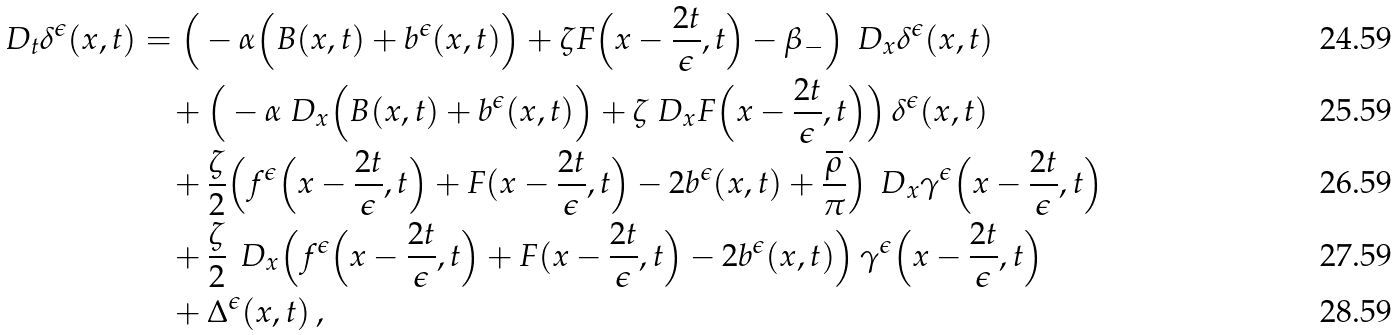Convert formula to latex. <formula><loc_0><loc_0><loc_500><loc_500>\ D _ { t } \delta ^ { \epsilon } ( x , t ) & = \Big ( - \alpha \Big ( B ( x , t ) + b ^ { \epsilon } ( x , t ) \Big ) + \zeta F \Big ( x - \frac { 2 t } { \epsilon } , t \Big ) - \beta _ { - } \Big ) \, \ D _ { x } \delta ^ { \epsilon } ( x , t ) \\ & \quad + \Big ( - \alpha \ D _ { x } \Big ( B ( x , t ) + b ^ { \epsilon } ( x , t ) \Big ) + \zeta \ D _ { x } F \Big ( x - \frac { 2 t } { \epsilon } , t \Big ) \Big ) \, \delta ^ { \epsilon } ( x , t ) \\ & \quad + \frac { \zeta } { 2 } \Big ( f ^ { \epsilon } \Big ( x - \frac { 2 t } { \epsilon } , t \Big ) + F ( x - \frac { 2 t } { \epsilon } , t \Big ) - 2 b ^ { \epsilon } ( x , t ) + \frac { \overline { \rho } } { \pi } \Big ) \, \ D _ { x } \gamma ^ { \epsilon } \Big ( x - \frac { 2 t } { \epsilon } , t \Big ) \\ & \quad + \frac { \zeta } { 2 } \, \ D _ { x } \Big ( f ^ { \epsilon } \Big ( x - \frac { 2 t } { \epsilon } , t \Big ) + F ( x - \frac { 2 t } { \epsilon } , t \Big ) - 2 b ^ { \epsilon } ( x , t ) \Big ) \, \gamma ^ { \epsilon } \Big ( x - \frac { 2 t } { \epsilon } , t \Big ) \\ & \quad + \Delta ^ { \epsilon } ( x , t ) \, ,</formula> 